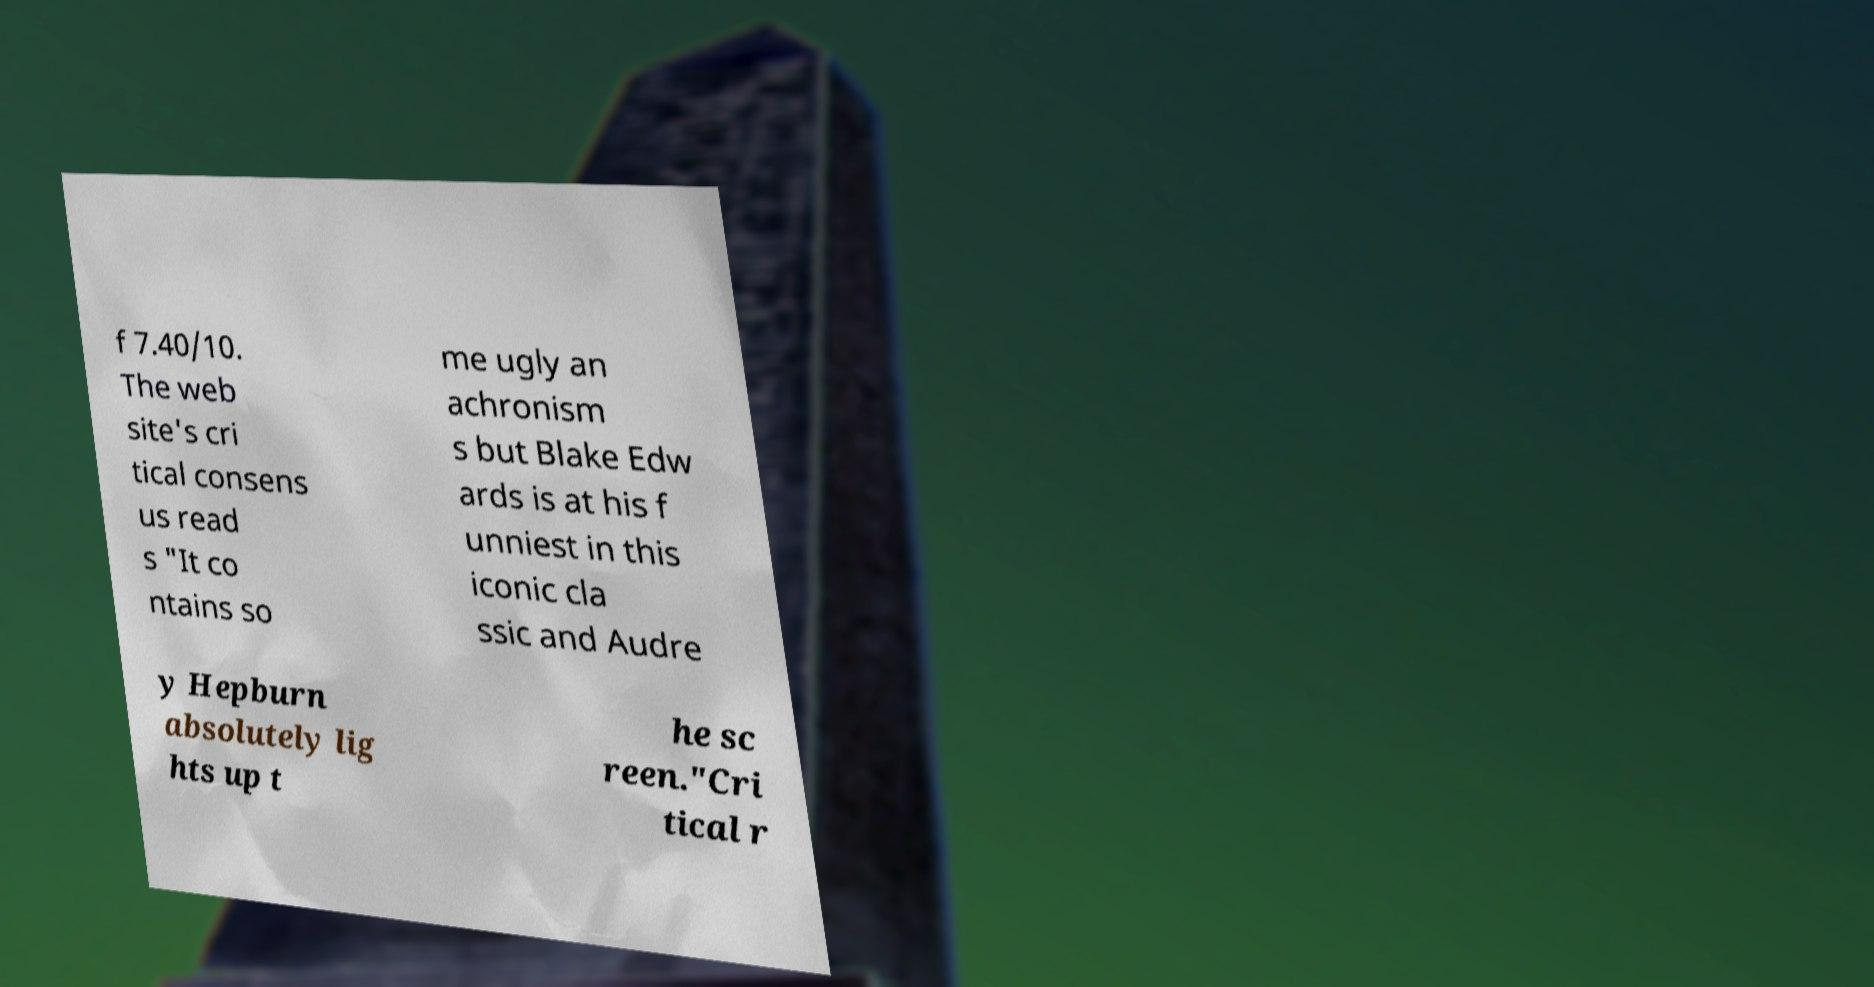Can you accurately transcribe the text from the provided image for me? f 7.40/10. The web site's cri tical consens us read s "It co ntains so me ugly an achronism s but Blake Edw ards is at his f unniest in this iconic cla ssic and Audre y Hepburn absolutely lig hts up t he sc reen."Cri tical r 